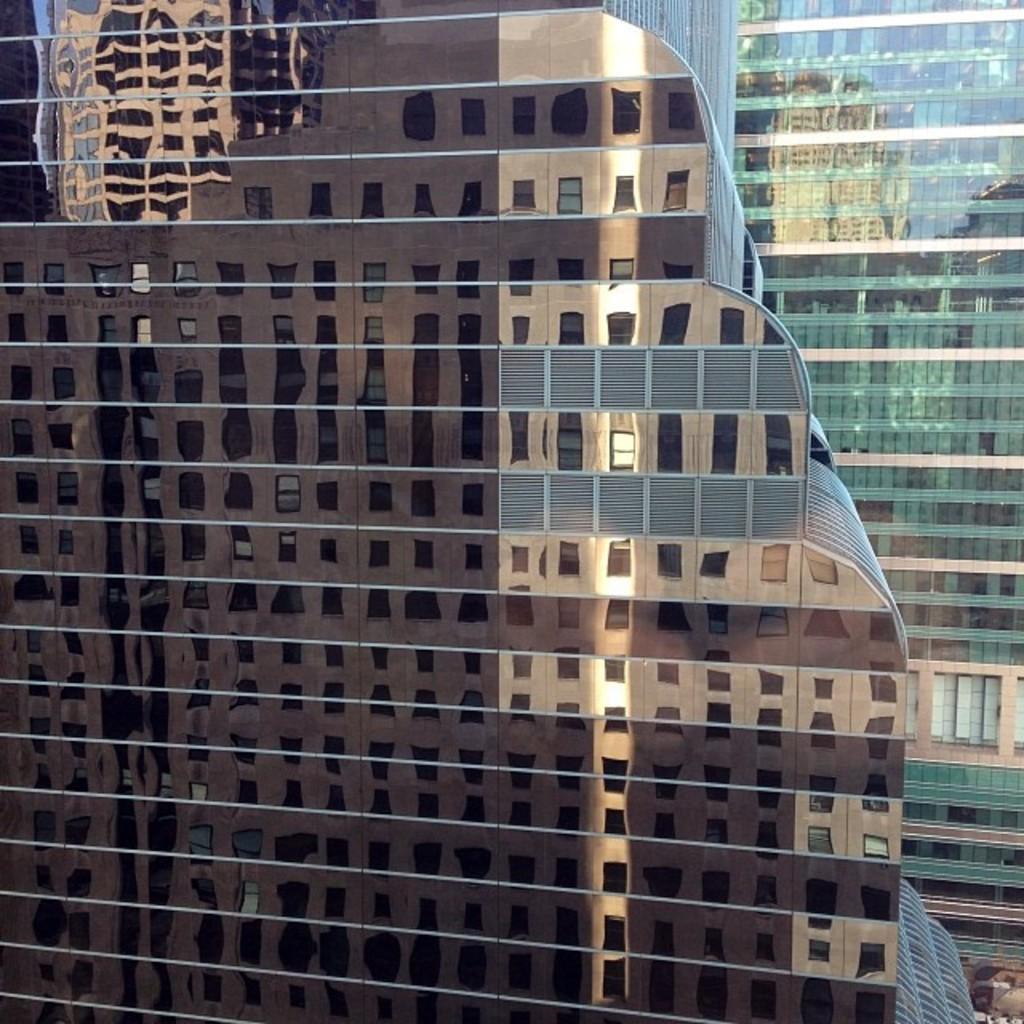How would you summarize this image in a sentence or two? In this image I can see a building which is brown in color and few windows of the building. In the background I can see another building which is green in color and on it I can see the reflection of another building. 